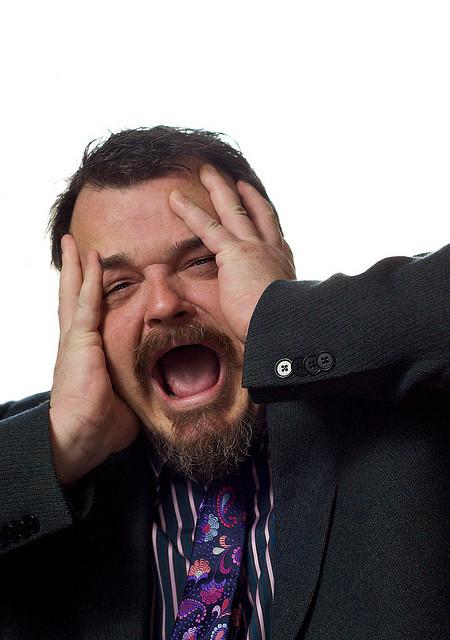Does his tie and shirt match?
Quick response, please. No. Does the man have a beard?
Write a very short answer. Yes. Is this man upset?
Answer briefly. Yes. 